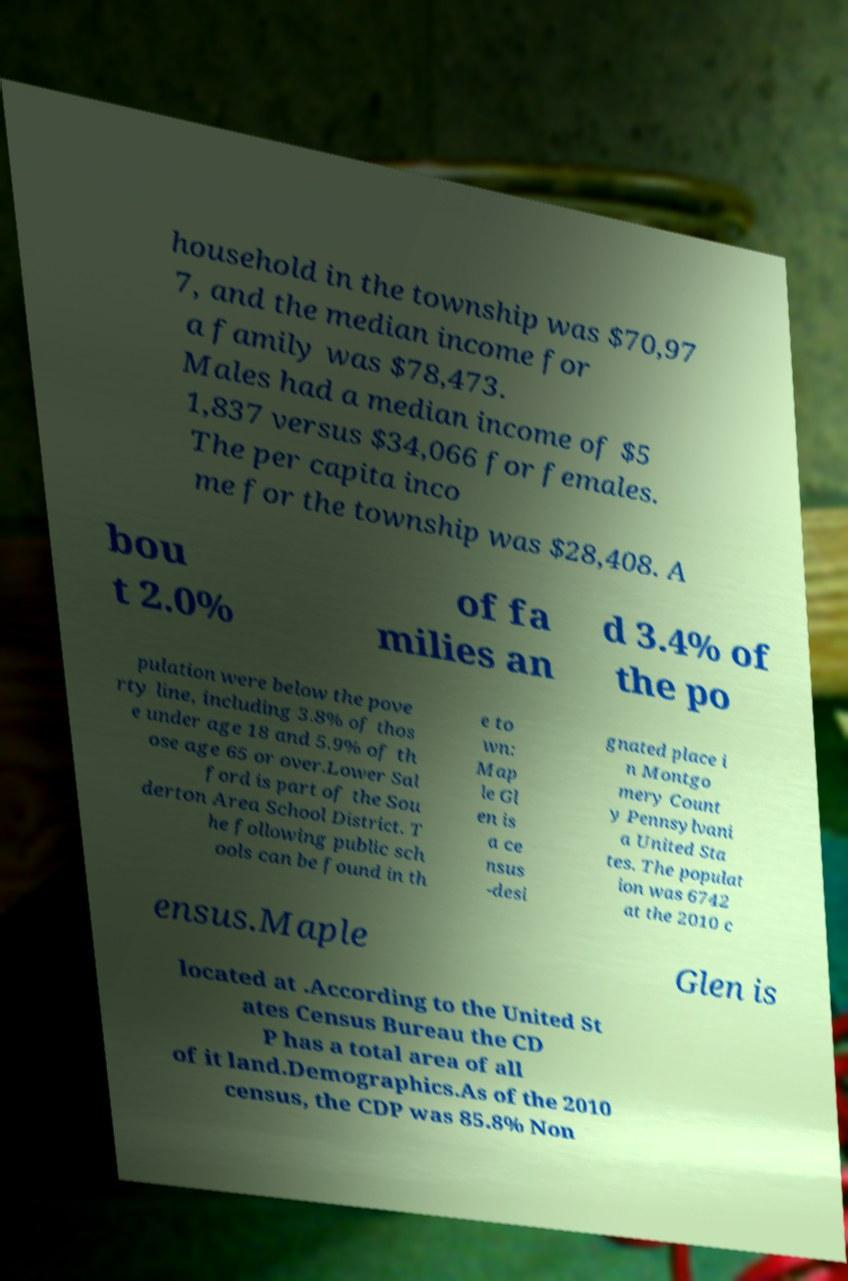There's text embedded in this image that I need extracted. Can you transcribe it verbatim? household in the township was $70,97 7, and the median income for a family was $78,473. Males had a median income of $5 1,837 versus $34,066 for females. The per capita inco me for the township was $28,408. A bou t 2.0% of fa milies an d 3.4% of the po pulation were below the pove rty line, including 3.8% of thos e under age 18 and 5.9% of th ose age 65 or over.Lower Sal ford is part of the Sou derton Area School District. T he following public sch ools can be found in th e to wn: Map le Gl en is a ce nsus -desi gnated place i n Montgo mery Count y Pennsylvani a United Sta tes. The populat ion was 6742 at the 2010 c ensus.Maple Glen is located at .According to the United St ates Census Bureau the CD P has a total area of all of it land.Demographics.As of the 2010 census, the CDP was 85.8% Non 